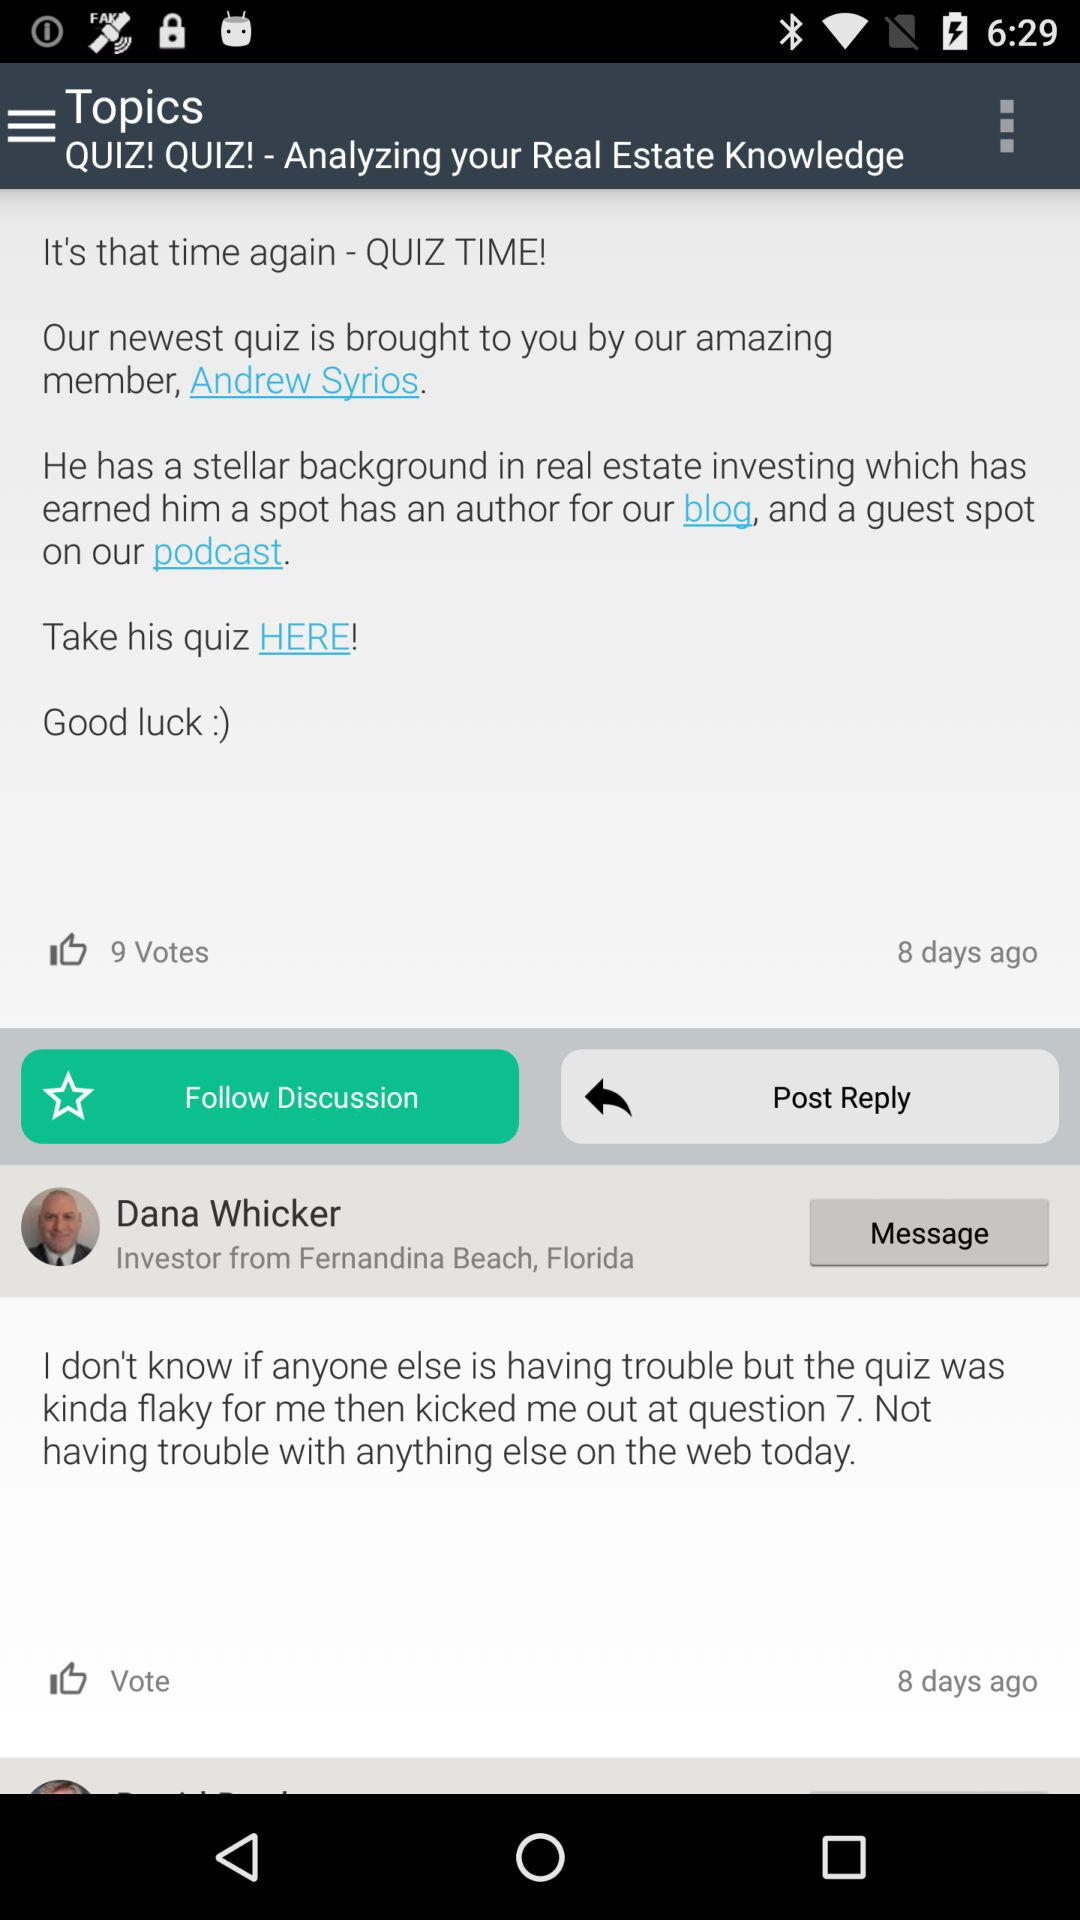What is the name of the investor from Fernandina Beach, Florida? The name of the investor is Dana Whicker. 